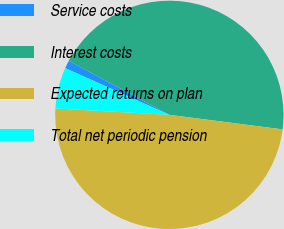Convert chart to OTSL. <chart><loc_0><loc_0><loc_500><loc_500><pie_chart><fcel>Service costs<fcel>Interest costs<fcel>Expected returns on plan<fcel>Total net periodic pension<nl><fcel>1.14%<fcel>44.18%<fcel>48.86%<fcel>5.82%<nl></chart> 